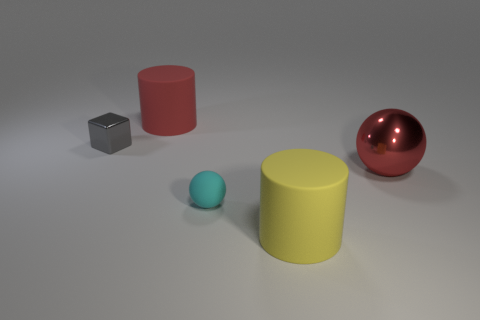Add 5 blue matte cubes. How many objects exist? 10 Subtract all red cylinders. How many cylinders are left? 1 Subtract all blocks. How many objects are left? 4 Subtract 1 cylinders. How many cylinders are left? 1 Subtract 0 green balls. How many objects are left? 5 Subtract all red balls. Subtract all blue cylinders. How many balls are left? 1 Subtract all big gray cubes. Subtract all tiny gray metal objects. How many objects are left? 4 Add 3 metal objects. How many metal objects are left? 5 Add 2 cyan metal cubes. How many cyan metal cubes exist? 2 